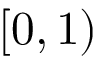Convert formula to latex. <formula><loc_0><loc_0><loc_500><loc_500>[ 0 , 1 )</formula> 